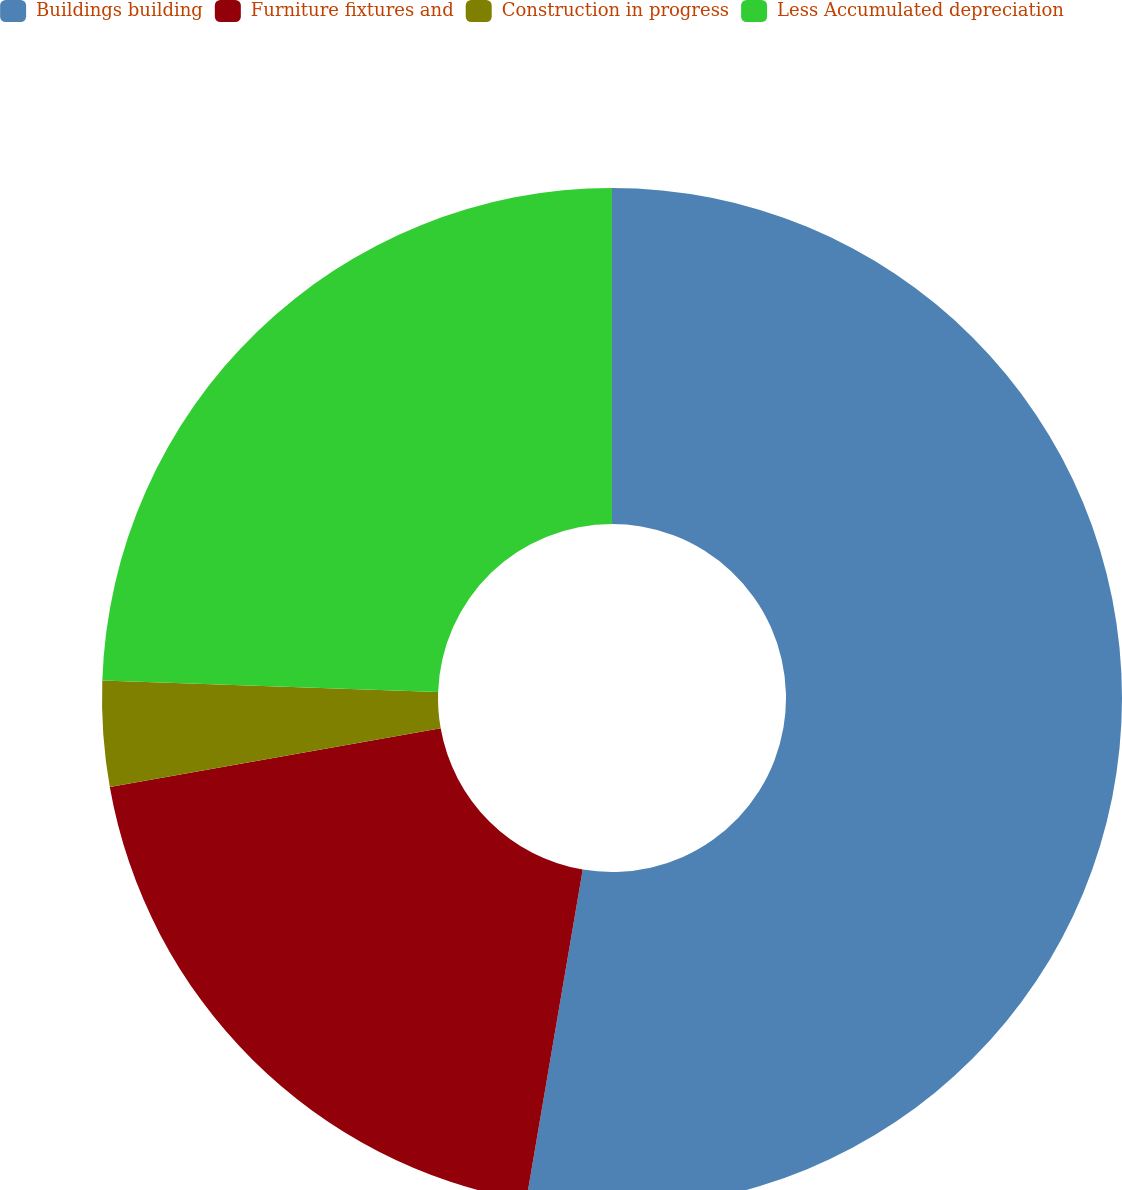Convert chart. <chart><loc_0><loc_0><loc_500><loc_500><pie_chart><fcel>Buildings building<fcel>Furniture fixtures and<fcel>Construction in progress<fcel>Less Accumulated depreciation<nl><fcel>52.69%<fcel>19.52%<fcel>3.34%<fcel>24.45%<nl></chart> 